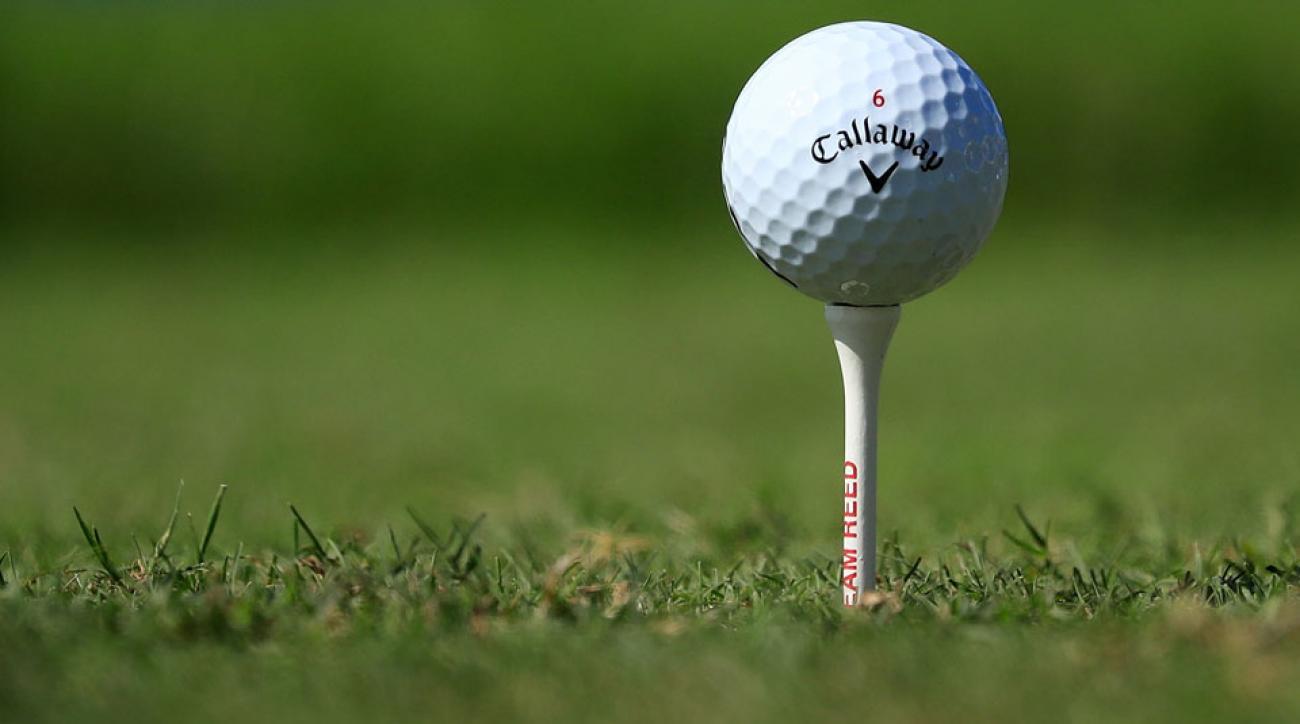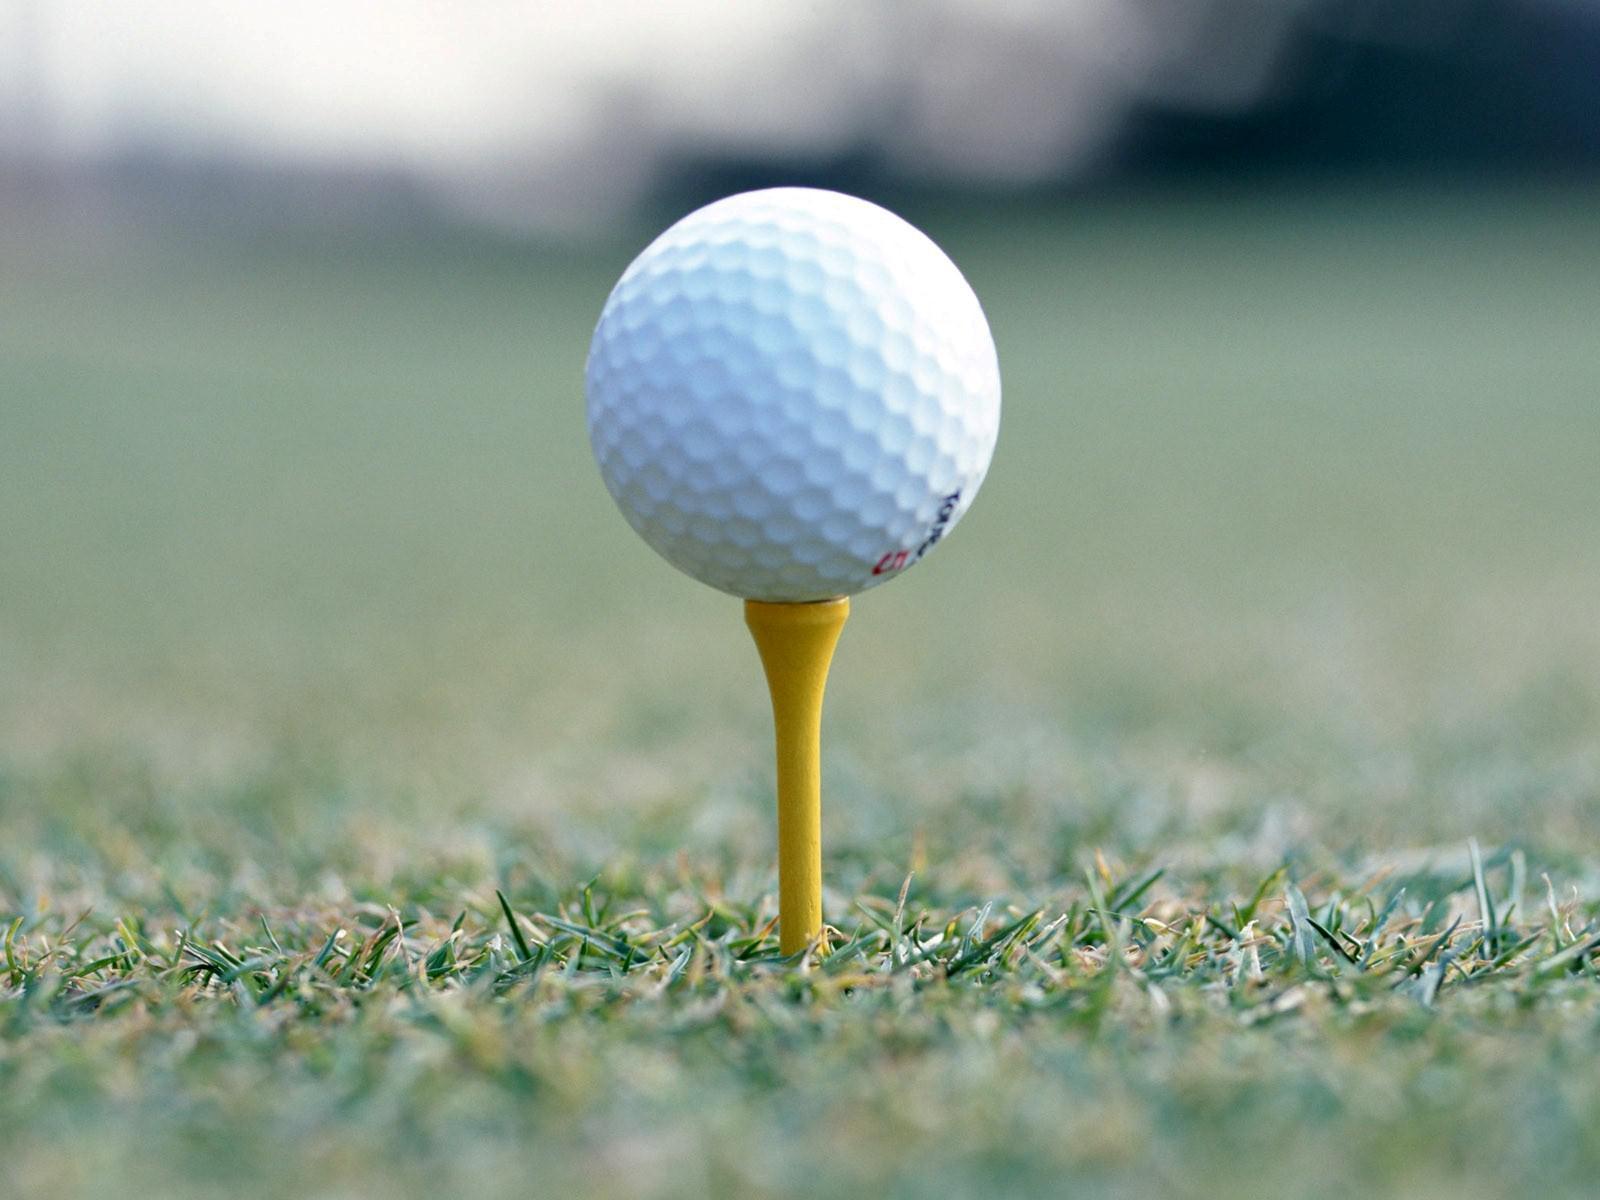The first image is the image on the left, the second image is the image on the right. Analyze the images presented: Is the assertion "All golf balls are sitting on tees in grassy areas." valid? Answer yes or no. Yes. 